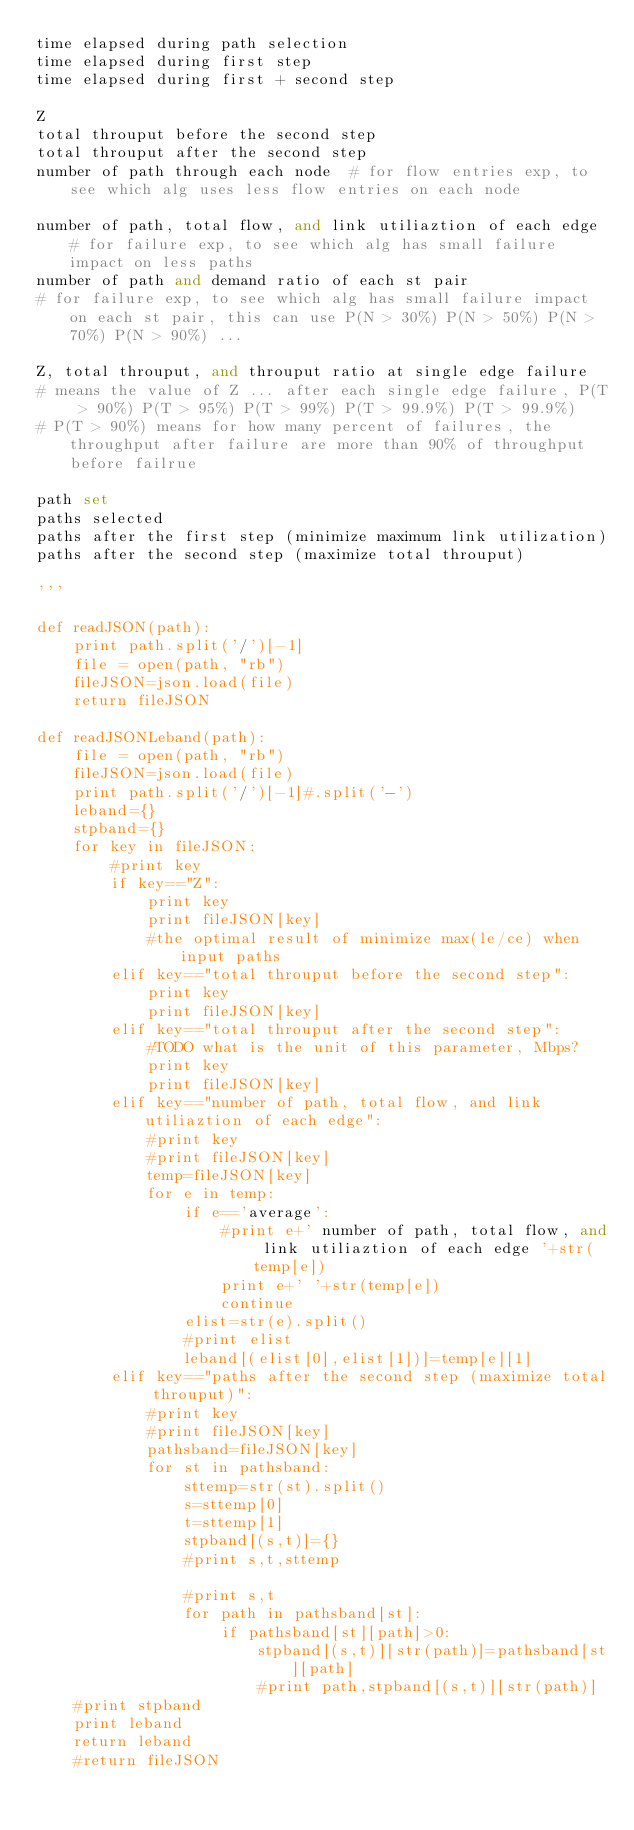<code> <loc_0><loc_0><loc_500><loc_500><_Python_>time elapsed during path selection
time elapsed during first step
time elapsed during first + second step

Z
total throuput before the second step
total throuput after the second step
number of path through each node  # for flow entries exp, to see which alg uses less flow entries on each node

number of path, total flow, and link utiliaztion of each edge # for failure exp, to see which alg has small failure impact on less paths
number of path and demand ratio of each st pair
# for failure exp, to see which alg has small failure impact on each st pair, this can use P(N > 30%) P(N > 50%) P(N > 70%) P(N > 90%) ...

Z, total throuput, and throuput ratio at single edge failure
# means the value of Z ... after each single edge failure, P(T > 90%) P(T > 95%) P(T > 99%) P(T > 99.9%) P(T > 99.9%)
# P(T > 90%) means for how many percent of failures, the throughput after failure are more than 90% of throughput before failrue

path set
paths selected
paths after the first step (minimize maximum link utilization)
paths after the second step (maximize total throuput)

'''

def readJSON(path):
    print path.split('/')[-1]
    file = open(path, "rb")
    fileJSON=json.load(file)
    return fileJSON

def readJSONLeband(path):
    file = open(path, "rb")
    fileJSON=json.load(file)
    print path.split('/')[-1]#.split('-')
    leband={}
    stpband={}
    for key in fileJSON:
        #print key
        if key=="Z":
            print key
            print fileJSON[key]
            #the optimal result of minimize max(le/ce) when input paths
        elif key=="total throuput before the second step":
            print key
            print fileJSON[key]
        elif key=="total throuput after the second step":
            #TODO what is the unit of this parameter, Mbps?
            print key
            print fileJSON[key]
        elif key=="number of path, total flow, and link utiliaztion of each edge":
            #print key
            #print fileJSON[key]
            temp=fileJSON[key]
            for e in temp:
                if e=='average':
                    #print e+' number of path, total flow, and link utiliaztion of each edge '+str(temp[e])
                    print e+' '+str(temp[e])
                    continue
                elist=str(e).split()
                #print elist
                leband[(elist[0],elist[1])]=temp[e][1]
        elif key=="paths after the second step (maximize total throuput)":
            #print key
            #print fileJSON[key]
            pathsband=fileJSON[key]
            for st in pathsband:
                sttemp=str(st).split()
                s=sttemp[0]
                t=sttemp[1]
                stpband[(s,t)]={}
                #print s,t,sttemp

                #print s,t
                for path in pathsband[st]:
                    if pathsband[st][path]>0:
                        stpband[(s,t)][str(path)]=pathsband[st][path]
                        #print path,stpband[(s,t)][str(path)]
    #print stpband
    print leband
    return leband
    #return fileJSON
</code> 